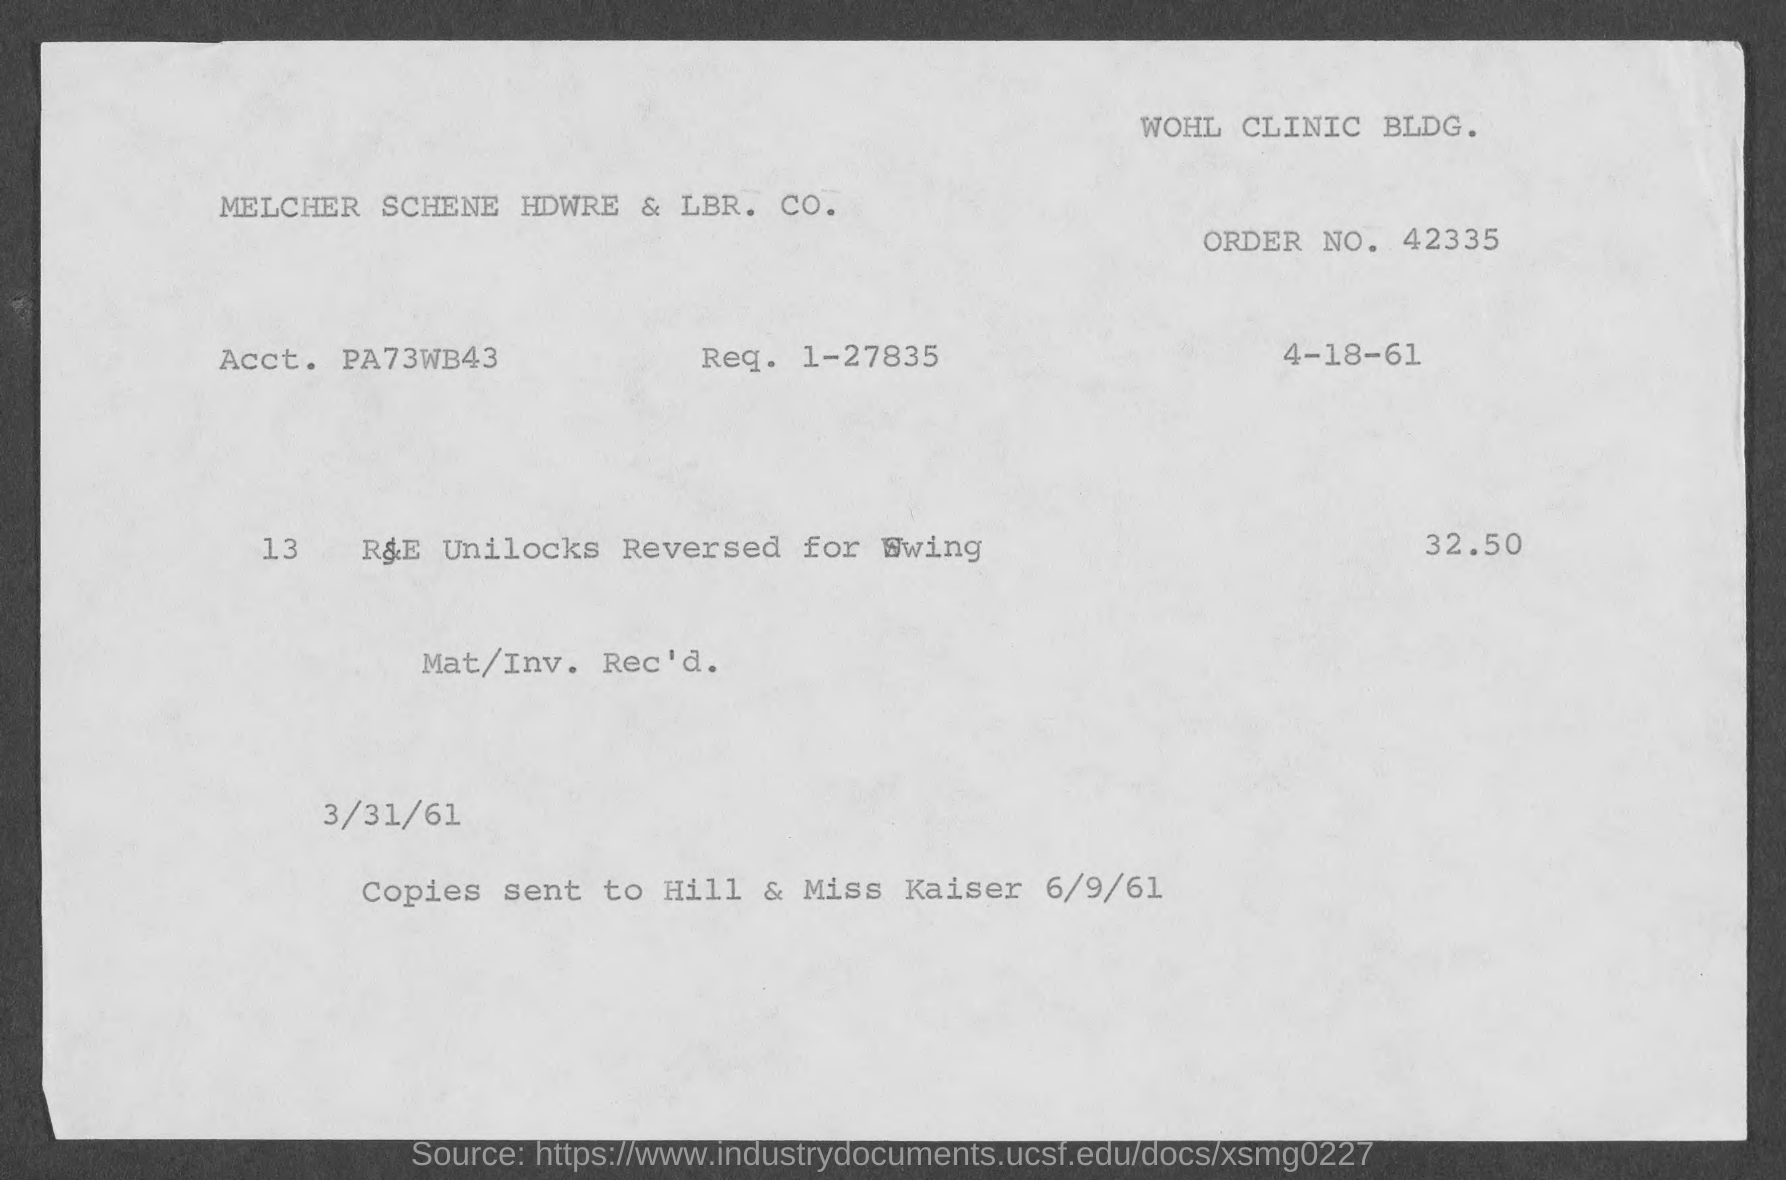What is the order no.?
Provide a succinct answer. 42335. What is the req. no?
Ensure brevity in your answer.  1-27835. 